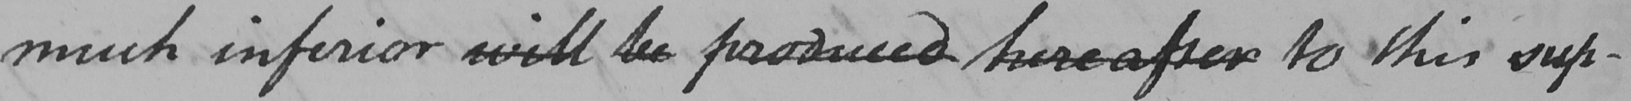What text is written in this handwritten line? much inferior will be produced hereafter to this sup- 